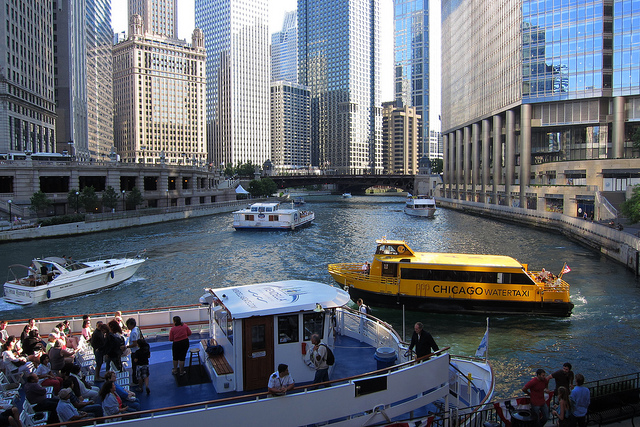Identify the text displayed in this image. CHICAGO WATERTAXI 